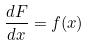<formula> <loc_0><loc_0><loc_500><loc_500>\frac { d F } { d x } = f ( x )</formula> 